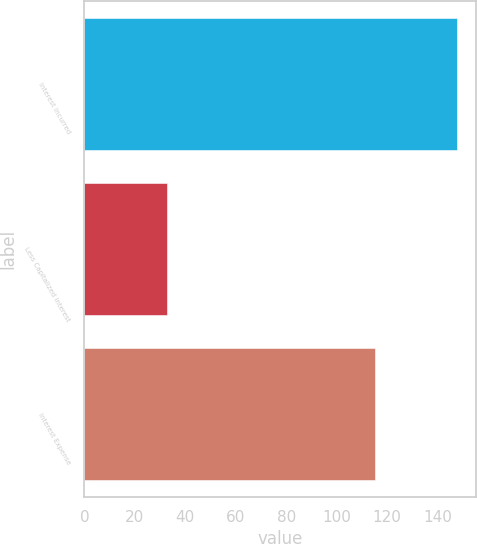<chart> <loc_0><loc_0><loc_500><loc_500><bar_chart><fcel>Interest incurred<fcel>Less Capitalized interest<fcel>Interest Expense<nl><fcel>147.9<fcel>32.7<fcel>115.2<nl></chart> 